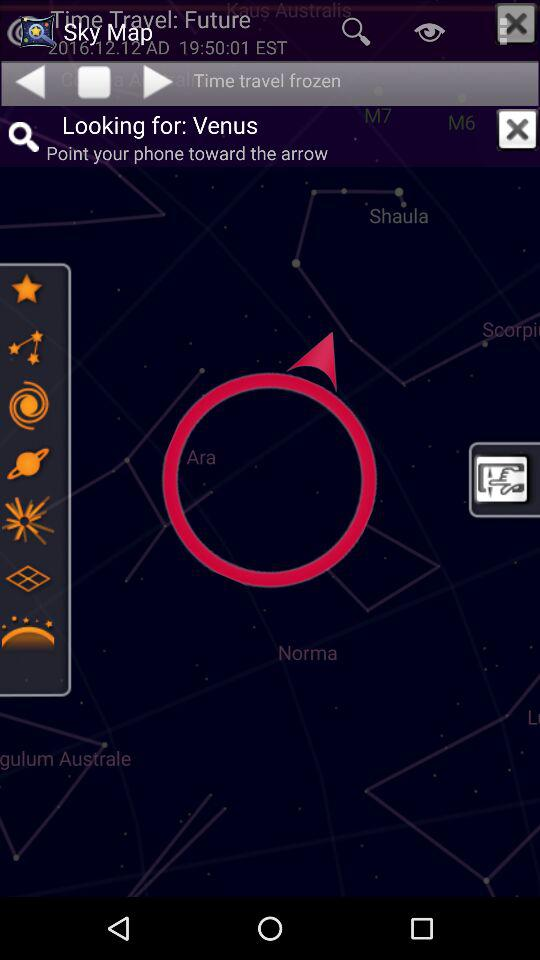What planet is the person looking for? The person is looking for Venus. 